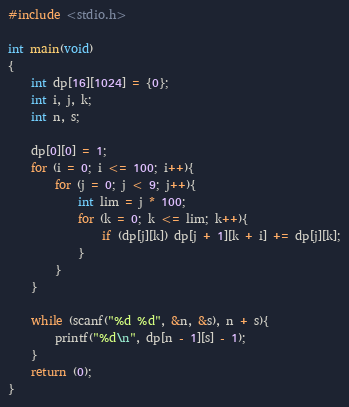<code> <loc_0><loc_0><loc_500><loc_500><_C_>#include <stdio.h>

int main(void)
{
	int dp[16][1024] = {0};
	int i, j, k;
	int n, s;

	dp[0][0] = 1;
	for (i = 0; i <= 100; i++){
		for (j = 0; j < 9; j++){
			int lim = j * 100;
			for (k = 0; k <= lim; k++){
				if (dp[j][k]) dp[j + 1][k + i] += dp[j][k];
			}
		}
	}

	while (scanf("%d %d", &n, &s), n + s){
		printf("%d\n", dp[n - 1][s] - 1);
	}
	return (0);
}</code> 